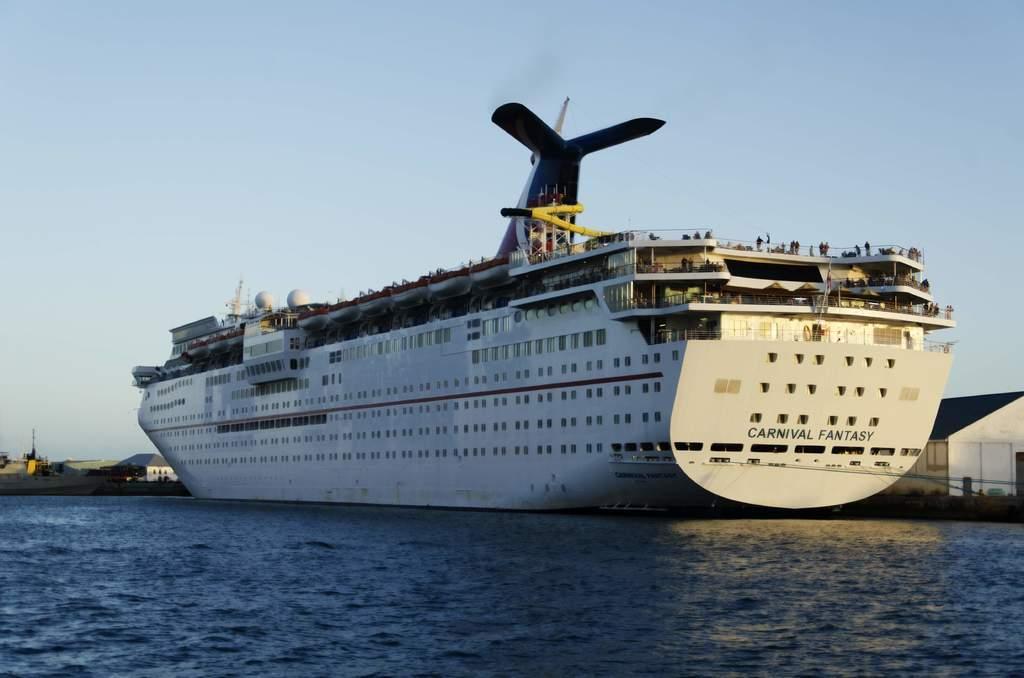Describe this image in one or two sentences. In this image there is a ship in the water. In the background of the image there are buildings and sky. 